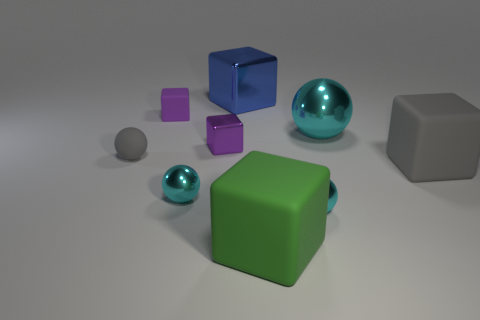How many cylinders are small metal things or tiny things? In the image provided, there are no objects that can be classified as cylinders; all depicted objects are either spherical or cubic in nature. Therefore, it is accurate to say that there are zero cylinders among the small metal things or tiny things present. 